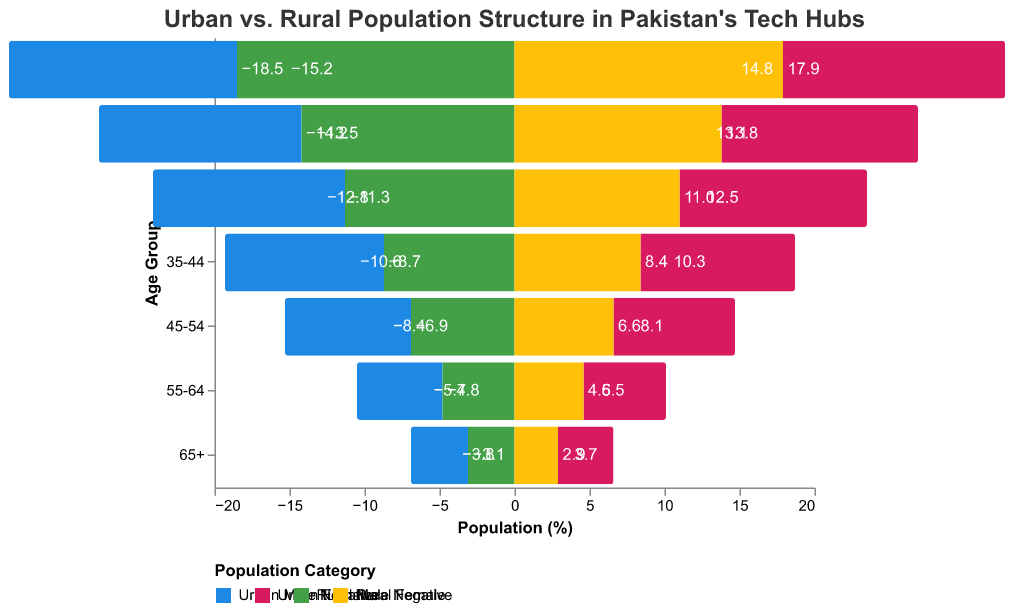What's the title of the figure? The title is given at the top of the figure, which explains the general theme or the subject being illustrated by the figure.
Answer: "Urban vs. Rural Population Structure in Pakistan's Tech Hubs" Which age group has the highest percentage of urban males? Look at the bars corresponding to different age groups and check which has the longest bar to the left side (negative part) for the category of "Urban Male."
Answer: 0-14 How does the percentage of rural females aged 55-64 compare to that of urban females aged 55-64? Compare the lengths of the bars for the 55-64 age group for "Rural Female" and "Urban Female" categories.
Answer: Rural Female is slightly less What is the percentage difference between urban males and rural males aged 15-24? Look at the respective bars for the 15-24 age group and subtract the values of "Rural Male" and "Urban Male."
Answer: 0.7 Which age group sees urban females having a higher percentage than rural females? For each age group, compare the length of bars for "Urban Female" and "Rural Female" to see where "Urban Female" is longer.
Answer: 25-34 Which gender has a closer population percentage in both urban and rural areas in the 45-54 age group? Compare the length of the bars for both "Urban Male" vs. "Rural Male" and "Urban Female" vs. "Rural Female" within the age range of 45-54.
Answer: Females Are there more males or females in the urban 35-44 age group? Check the length of bars for "Urban Male" and "Urban Female" within the 35-44 age group.
Answer: Males What percentage of the population is under 15 in rural areas compared to urban areas? Add the "Rural Male" and "Rural Female" values for the 0-14 age group and compare it to the sum of "Urban Male" and "Urban Female" for the same age group.
Answer: Rural (36.4%) is higher than Urban (30.0%) What is the overall pattern for the age distribution in rural vs. urban populations as it relates to technology hubs? Analyze the figure for a general trend. Urban areas tend to have more even age distribution, while rural areas have a higher percentage in younger age groups.
Answer: Urban areas have a more even age distribution, rural areas have a higher proportion of younger individuals 